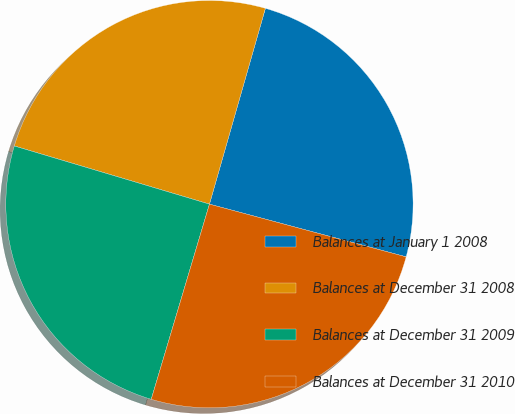Convert chart. <chart><loc_0><loc_0><loc_500><loc_500><pie_chart><fcel>Balances at January 1 2008<fcel>Balances at December 31 2008<fcel>Balances at December 31 2009<fcel>Balances at December 31 2010<nl><fcel>24.74%<fcel>24.82%<fcel>25.0%<fcel>25.45%<nl></chart> 